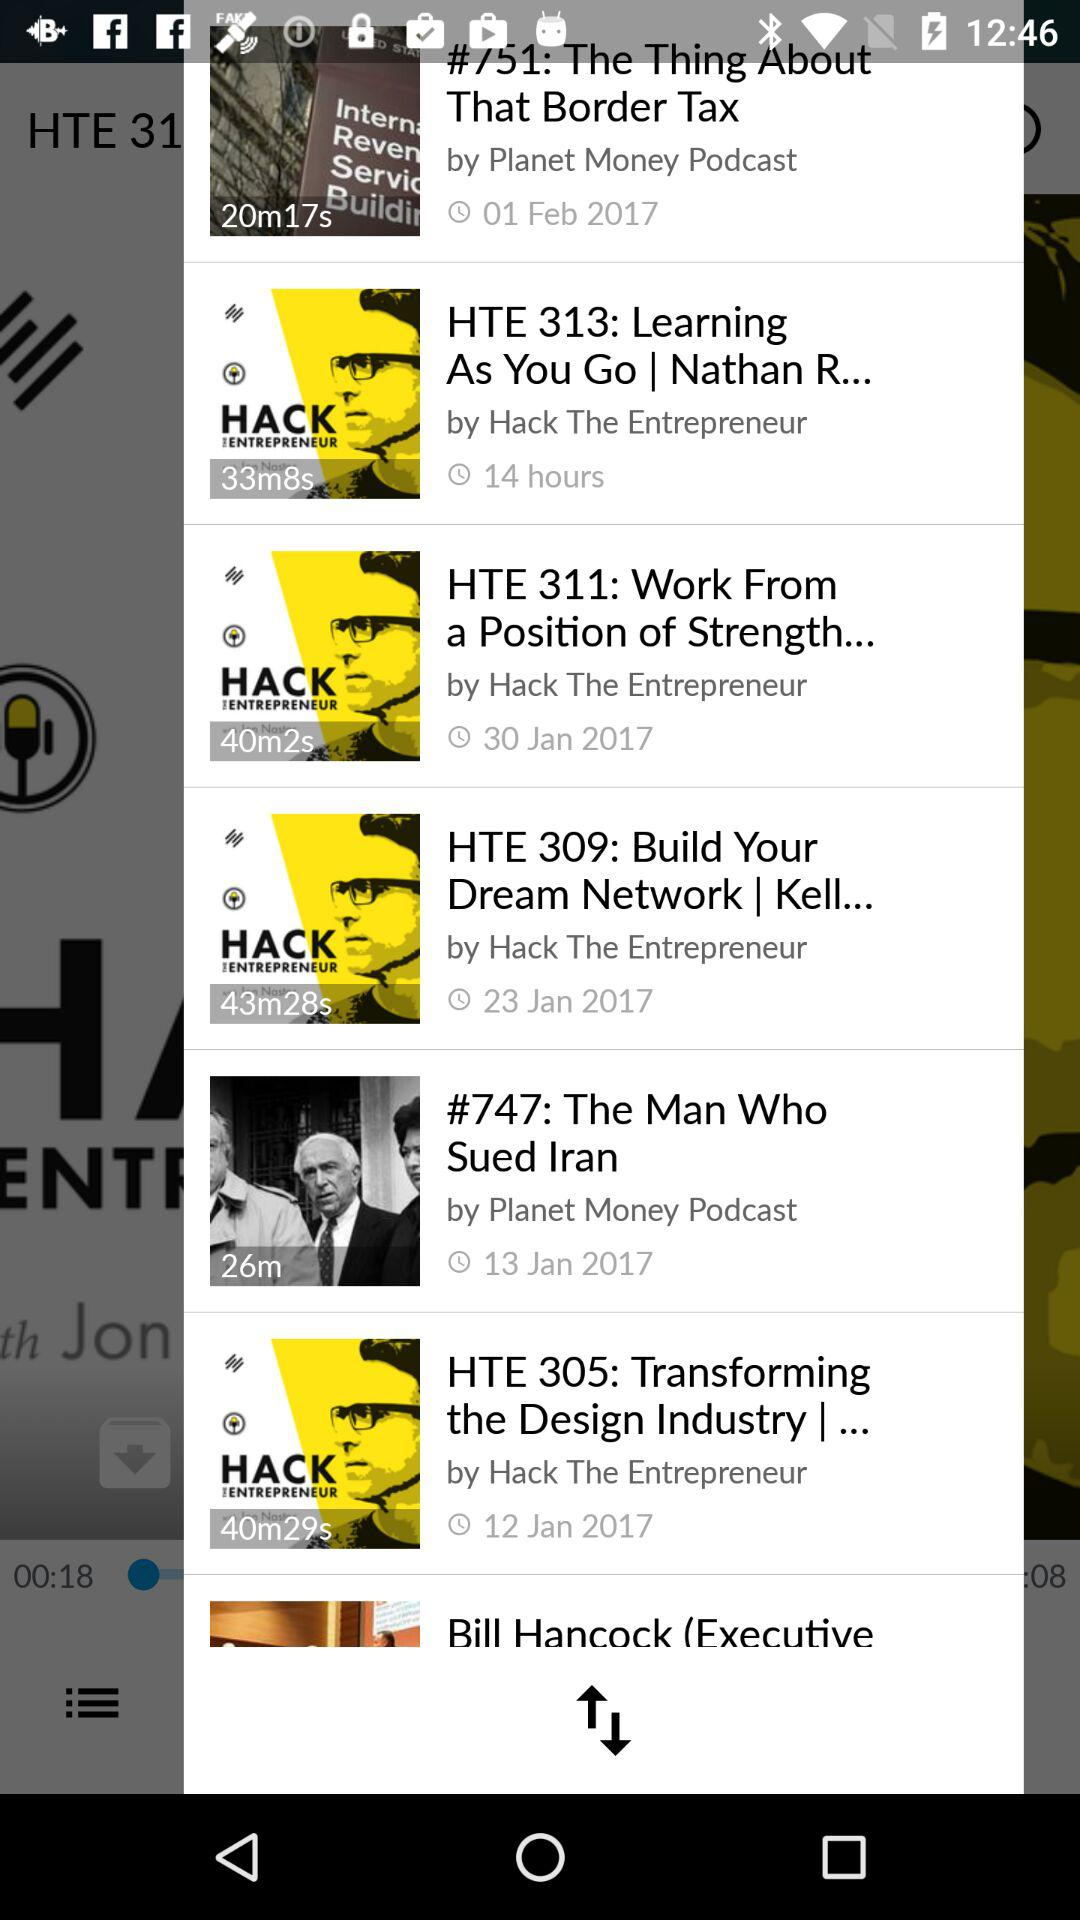What is the given date of "The Man Who Sued Iran"? The given date is January 13, 2017. 